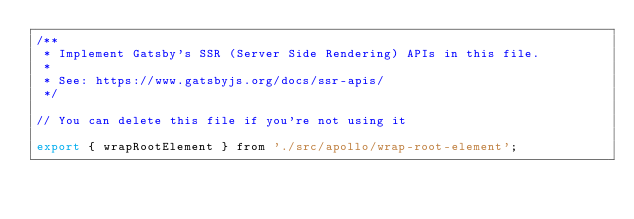<code> <loc_0><loc_0><loc_500><loc_500><_JavaScript_>/**
 * Implement Gatsby's SSR (Server Side Rendering) APIs in this file.
 *
 * See: https://www.gatsbyjs.org/docs/ssr-apis/
 */

// You can delete this file if you're not using it

export { wrapRootElement } from './src/apollo/wrap-root-element';</code> 